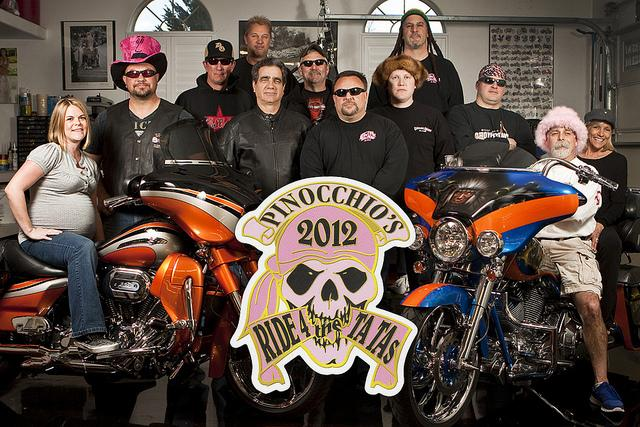What type of cancer charity are they supporting? Please explain your reasoning. breast. The term tatas is slang for a woman's chest. 